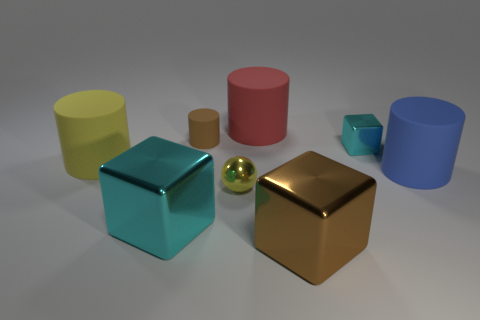The large metal object that is the same color as the tiny cylinder is what shape?
Your answer should be very brief. Cube. There is a big thing that is in front of the large cyan metal cube; what material is it?
Offer a very short reply. Metal. What number of yellow shiny objects are the same shape as the tiny cyan metallic object?
Make the answer very short. 0. There is a yellow thing that is made of the same material as the small cyan thing; what shape is it?
Make the answer very short. Sphere. The thing in front of the cyan object that is in front of the cyan cube on the right side of the red rubber thing is what shape?
Provide a short and direct response. Cube. Is the number of big blue matte cylinders greater than the number of cyan metal cubes?
Provide a short and direct response. No. There is a large brown object that is the same shape as the tiny cyan thing; what is it made of?
Provide a succinct answer. Metal. Is the material of the large yellow cylinder the same as the small brown thing?
Ensure brevity in your answer.  Yes. Is the number of yellow metal objects behind the yellow shiny object greater than the number of large cubes?
Your answer should be very brief. No. There is a block in front of the cyan block that is to the left of the cube that is to the right of the big brown metal thing; what is it made of?
Give a very brief answer. Metal. 